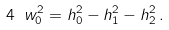<formula> <loc_0><loc_0><loc_500><loc_500>4 \ w ^ { 2 } _ { 0 } = h ^ { 2 } _ { 0 } - h ^ { 2 } _ { 1 } - h ^ { 2 } _ { 2 } \, .</formula> 